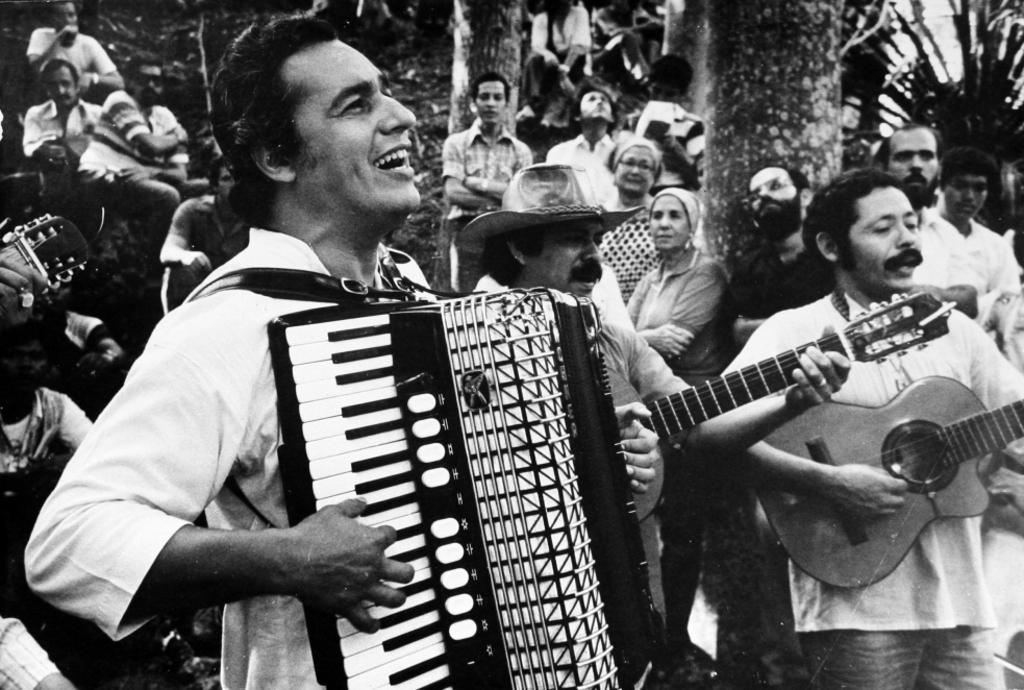What is the color scheme of the image? The image is black and white. What activity are some people engaged in within the image? There are people playing a musical instrument in the image. Can you describe the group of people in the background of the image? There are many people standing far away in the image. What type of body is visible in the image? There is no body present in the image; it features people playing a musical instrument and others standing far away. Is there any smoke coming from the musical instrument in the image? There is no smoke visible in the image; it is a black and white photograph. 